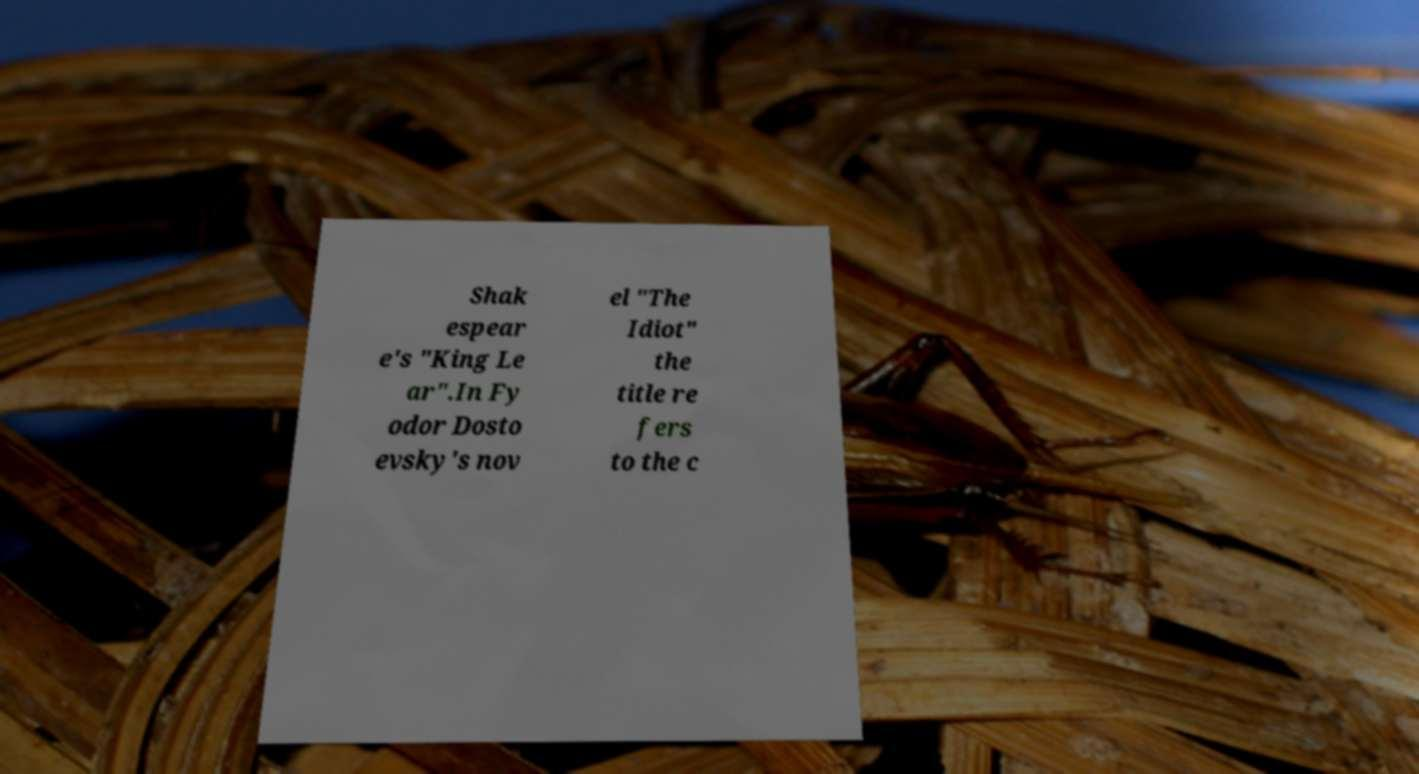Can you read and provide the text displayed in the image?This photo seems to have some interesting text. Can you extract and type it out for me? Shak espear e's "King Le ar".In Fy odor Dosto evsky's nov el "The Idiot" the title re fers to the c 